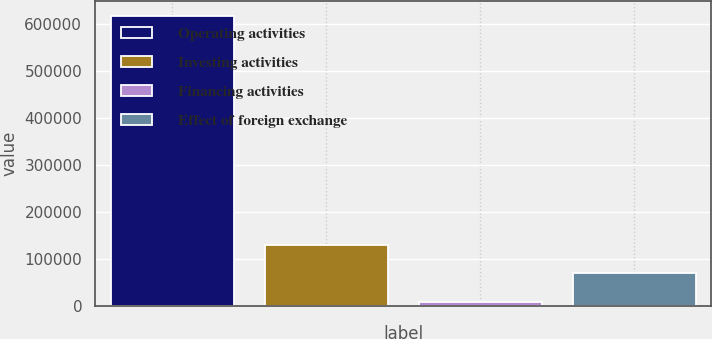Convert chart. <chart><loc_0><loc_0><loc_500><loc_500><bar_chart><fcel>Operating activities<fcel>Investing activities<fcel>Financing activities<fcel>Effect of foreign exchange<nl><fcel>617440<fcel>131306<fcel>9772<fcel>70538.8<nl></chart> 